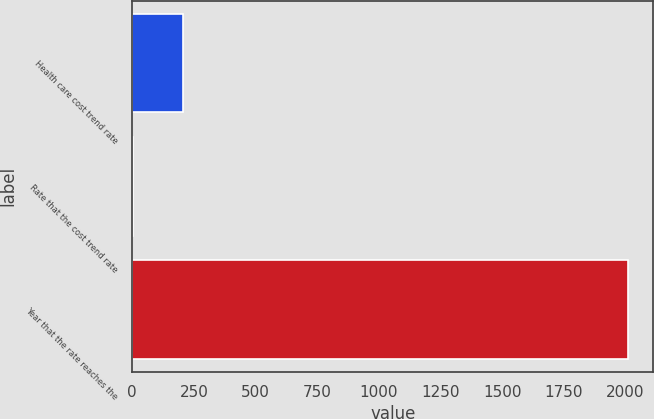Convert chart to OTSL. <chart><loc_0><loc_0><loc_500><loc_500><bar_chart><fcel>Health care cost trend rate<fcel>Rate that the cost trend rate<fcel>Year that the rate reaches the<nl><fcel>205.7<fcel>5<fcel>2012<nl></chart> 